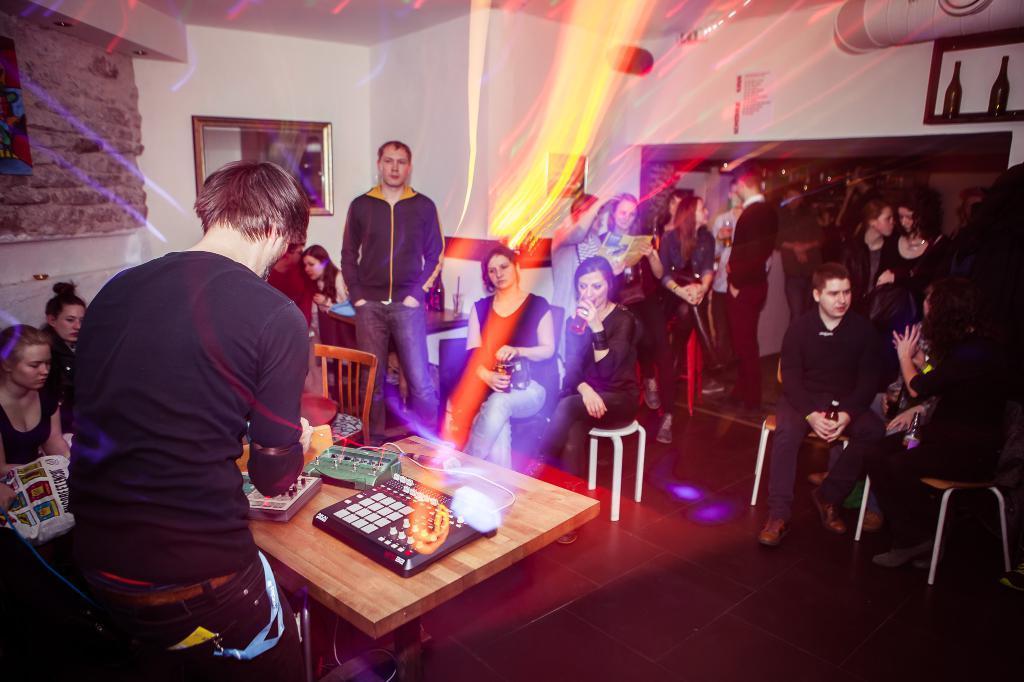In one or two sentences, can you explain what this image depicts? In this image there are group of persons, the persons are holding an object, there are chairs, there is a table, there are objects on the table, there is an object towards the left of the image, there is the wall, there are objects on the wall, there are bottles, there is an object towards the top of the image, there is a wooden flooring towards the bottom of the image. 